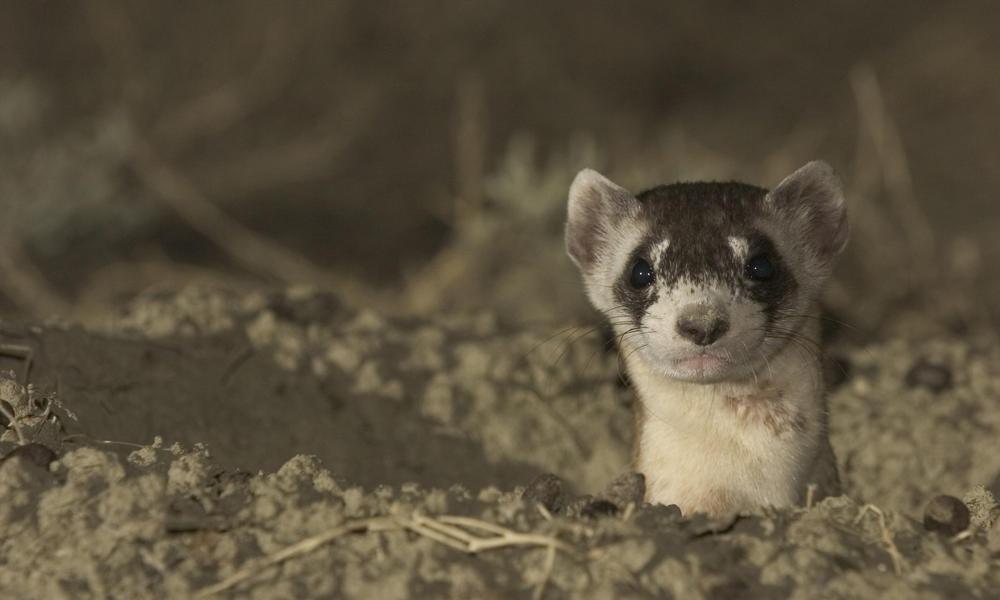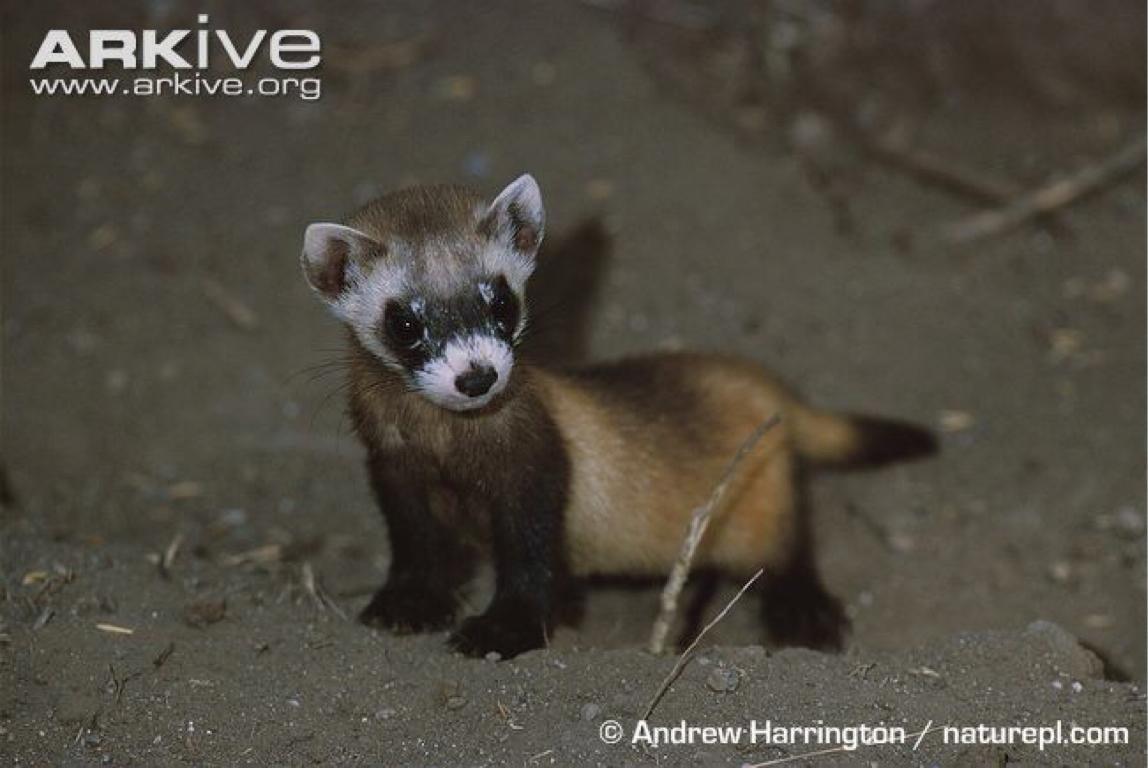The first image is the image on the left, the second image is the image on the right. For the images displayed, is the sentence "The animal in the image on the right is in side profile turned toward the left with its face turned toward the camera." factually correct? Answer yes or no. Yes. 